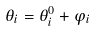<formula> <loc_0><loc_0><loc_500><loc_500>\theta _ { i } = \theta _ { i } ^ { 0 } + \varphi _ { i }</formula> 